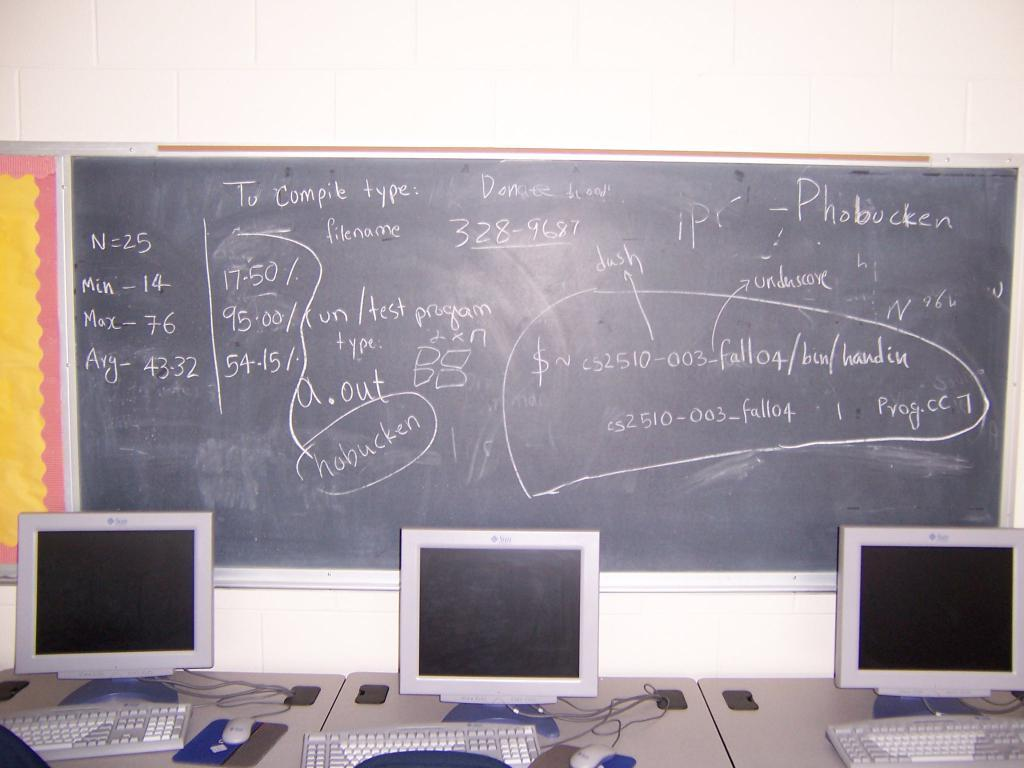<image>
Describe the image concisely. A black board with Phobucken written on it is behind three computer monitors. 